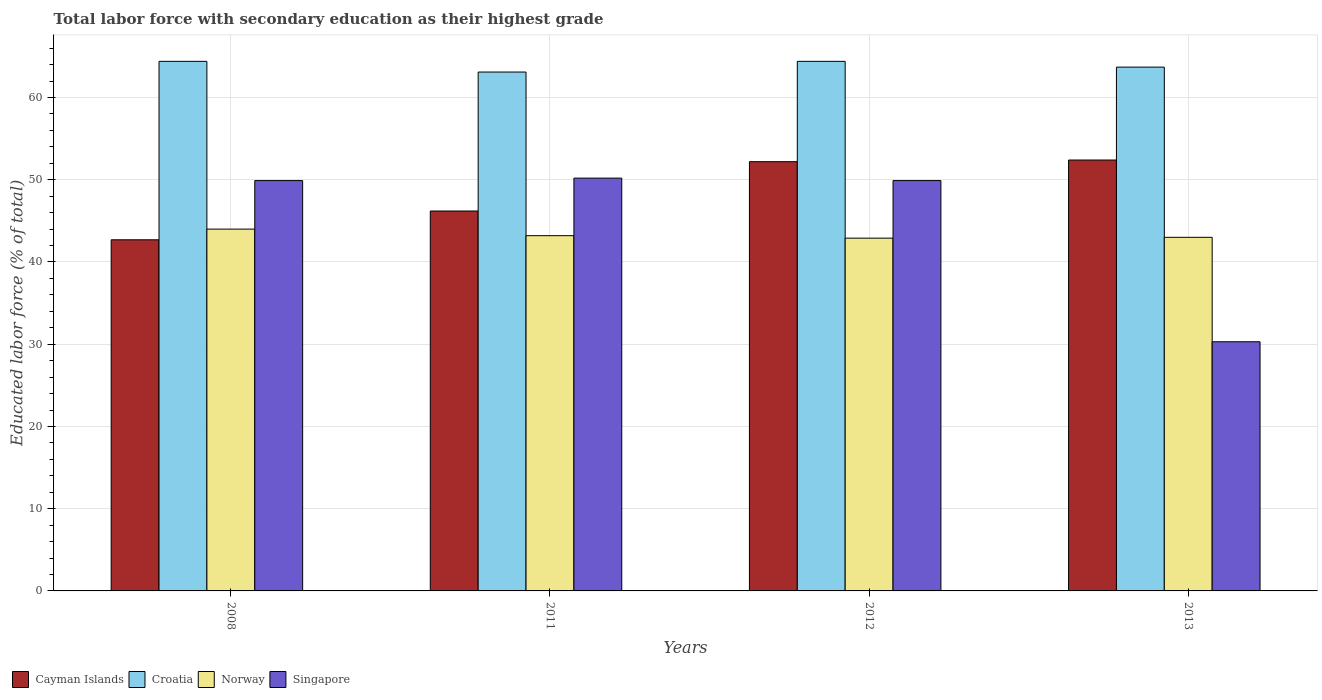Are the number of bars per tick equal to the number of legend labels?
Give a very brief answer. Yes. How many bars are there on the 1st tick from the left?
Your answer should be very brief. 4. How many bars are there on the 2nd tick from the right?
Offer a very short reply. 4. In how many cases, is the number of bars for a given year not equal to the number of legend labels?
Keep it short and to the point. 0. What is the percentage of total labor force with primary education in Croatia in 2008?
Your answer should be very brief. 64.4. Across all years, what is the maximum percentage of total labor force with primary education in Cayman Islands?
Your response must be concise. 52.4. Across all years, what is the minimum percentage of total labor force with primary education in Croatia?
Your answer should be compact. 63.1. In which year was the percentage of total labor force with primary education in Norway maximum?
Offer a terse response. 2008. What is the total percentage of total labor force with primary education in Croatia in the graph?
Offer a very short reply. 255.6. What is the difference between the percentage of total labor force with primary education in Cayman Islands in 2011 and the percentage of total labor force with primary education in Croatia in 2008?
Make the answer very short. -18.2. What is the average percentage of total labor force with primary education in Norway per year?
Provide a short and direct response. 43.28. In the year 2012, what is the difference between the percentage of total labor force with primary education in Croatia and percentage of total labor force with primary education in Norway?
Provide a short and direct response. 21.5. What is the ratio of the percentage of total labor force with primary education in Singapore in 2011 to that in 2013?
Offer a terse response. 1.66. Is the percentage of total labor force with primary education in Singapore in 2008 less than that in 2011?
Offer a very short reply. Yes. What is the difference between the highest and the second highest percentage of total labor force with primary education in Cayman Islands?
Offer a very short reply. 0.2. What is the difference between the highest and the lowest percentage of total labor force with primary education in Croatia?
Offer a very short reply. 1.3. Is it the case that in every year, the sum of the percentage of total labor force with primary education in Cayman Islands and percentage of total labor force with primary education in Singapore is greater than the sum of percentage of total labor force with primary education in Norway and percentage of total labor force with primary education in Croatia?
Your answer should be very brief. No. What does the 4th bar from the left in 2011 represents?
Your answer should be compact. Singapore. What does the 4th bar from the right in 2011 represents?
Offer a terse response. Cayman Islands. Are the values on the major ticks of Y-axis written in scientific E-notation?
Give a very brief answer. No. How are the legend labels stacked?
Ensure brevity in your answer.  Horizontal. What is the title of the graph?
Your answer should be very brief. Total labor force with secondary education as their highest grade. What is the label or title of the X-axis?
Provide a short and direct response. Years. What is the label or title of the Y-axis?
Offer a very short reply. Educated labor force (% of total). What is the Educated labor force (% of total) in Cayman Islands in 2008?
Keep it short and to the point. 42.7. What is the Educated labor force (% of total) of Croatia in 2008?
Your response must be concise. 64.4. What is the Educated labor force (% of total) of Singapore in 2008?
Keep it short and to the point. 49.9. What is the Educated labor force (% of total) of Cayman Islands in 2011?
Offer a very short reply. 46.2. What is the Educated labor force (% of total) of Croatia in 2011?
Offer a terse response. 63.1. What is the Educated labor force (% of total) in Norway in 2011?
Offer a very short reply. 43.2. What is the Educated labor force (% of total) in Singapore in 2011?
Ensure brevity in your answer.  50.2. What is the Educated labor force (% of total) of Cayman Islands in 2012?
Make the answer very short. 52.2. What is the Educated labor force (% of total) of Croatia in 2012?
Make the answer very short. 64.4. What is the Educated labor force (% of total) of Norway in 2012?
Offer a very short reply. 42.9. What is the Educated labor force (% of total) in Singapore in 2012?
Offer a very short reply. 49.9. What is the Educated labor force (% of total) of Cayman Islands in 2013?
Your answer should be compact. 52.4. What is the Educated labor force (% of total) in Croatia in 2013?
Offer a very short reply. 63.7. What is the Educated labor force (% of total) in Norway in 2013?
Your answer should be very brief. 43. What is the Educated labor force (% of total) of Singapore in 2013?
Keep it short and to the point. 30.3. Across all years, what is the maximum Educated labor force (% of total) in Cayman Islands?
Provide a succinct answer. 52.4. Across all years, what is the maximum Educated labor force (% of total) of Croatia?
Make the answer very short. 64.4. Across all years, what is the maximum Educated labor force (% of total) in Norway?
Keep it short and to the point. 44. Across all years, what is the maximum Educated labor force (% of total) in Singapore?
Your response must be concise. 50.2. Across all years, what is the minimum Educated labor force (% of total) in Cayman Islands?
Your answer should be very brief. 42.7. Across all years, what is the minimum Educated labor force (% of total) of Croatia?
Your answer should be very brief. 63.1. Across all years, what is the minimum Educated labor force (% of total) in Norway?
Provide a short and direct response. 42.9. Across all years, what is the minimum Educated labor force (% of total) of Singapore?
Make the answer very short. 30.3. What is the total Educated labor force (% of total) in Cayman Islands in the graph?
Your response must be concise. 193.5. What is the total Educated labor force (% of total) in Croatia in the graph?
Make the answer very short. 255.6. What is the total Educated labor force (% of total) of Norway in the graph?
Your answer should be very brief. 173.1. What is the total Educated labor force (% of total) in Singapore in the graph?
Ensure brevity in your answer.  180.3. What is the difference between the Educated labor force (% of total) in Cayman Islands in 2008 and that in 2011?
Offer a very short reply. -3.5. What is the difference between the Educated labor force (% of total) of Norway in 2008 and that in 2012?
Provide a succinct answer. 1.1. What is the difference between the Educated labor force (% of total) in Cayman Islands in 2008 and that in 2013?
Provide a short and direct response. -9.7. What is the difference between the Educated labor force (% of total) of Singapore in 2008 and that in 2013?
Your answer should be compact. 19.6. What is the difference between the Educated labor force (% of total) in Cayman Islands in 2011 and that in 2012?
Your response must be concise. -6. What is the difference between the Educated labor force (% of total) of Croatia in 2011 and that in 2012?
Your answer should be very brief. -1.3. What is the difference between the Educated labor force (% of total) of Norway in 2011 and that in 2012?
Provide a short and direct response. 0.3. What is the difference between the Educated labor force (% of total) in Singapore in 2011 and that in 2012?
Your response must be concise. 0.3. What is the difference between the Educated labor force (% of total) in Croatia in 2011 and that in 2013?
Make the answer very short. -0.6. What is the difference between the Educated labor force (% of total) in Norway in 2011 and that in 2013?
Ensure brevity in your answer.  0.2. What is the difference between the Educated labor force (% of total) in Singapore in 2012 and that in 2013?
Your response must be concise. 19.6. What is the difference between the Educated labor force (% of total) of Cayman Islands in 2008 and the Educated labor force (% of total) of Croatia in 2011?
Offer a very short reply. -20.4. What is the difference between the Educated labor force (% of total) of Croatia in 2008 and the Educated labor force (% of total) of Norway in 2011?
Your response must be concise. 21.2. What is the difference between the Educated labor force (% of total) of Cayman Islands in 2008 and the Educated labor force (% of total) of Croatia in 2012?
Ensure brevity in your answer.  -21.7. What is the difference between the Educated labor force (% of total) of Cayman Islands in 2008 and the Educated labor force (% of total) of Singapore in 2012?
Make the answer very short. -7.2. What is the difference between the Educated labor force (% of total) in Norway in 2008 and the Educated labor force (% of total) in Singapore in 2012?
Keep it short and to the point. -5.9. What is the difference between the Educated labor force (% of total) of Cayman Islands in 2008 and the Educated labor force (% of total) of Croatia in 2013?
Provide a succinct answer. -21. What is the difference between the Educated labor force (% of total) in Cayman Islands in 2008 and the Educated labor force (% of total) in Norway in 2013?
Keep it short and to the point. -0.3. What is the difference between the Educated labor force (% of total) in Cayman Islands in 2008 and the Educated labor force (% of total) in Singapore in 2013?
Provide a short and direct response. 12.4. What is the difference between the Educated labor force (% of total) in Croatia in 2008 and the Educated labor force (% of total) in Norway in 2013?
Make the answer very short. 21.4. What is the difference between the Educated labor force (% of total) of Croatia in 2008 and the Educated labor force (% of total) of Singapore in 2013?
Your response must be concise. 34.1. What is the difference between the Educated labor force (% of total) of Norway in 2008 and the Educated labor force (% of total) of Singapore in 2013?
Your answer should be compact. 13.7. What is the difference between the Educated labor force (% of total) of Cayman Islands in 2011 and the Educated labor force (% of total) of Croatia in 2012?
Offer a terse response. -18.2. What is the difference between the Educated labor force (% of total) of Cayman Islands in 2011 and the Educated labor force (% of total) of Norway in 2012?
Give a very brief answer. 3.3. What is the difference between the Educated labor force (% of total) in Cayman Islands in 2011 and the Educated labor force (% of total) in Singapore in 2012?
Keep it short and to the point. -3.7. What is the difference between the Educated labor force (% of total) of Croatia in 2011 and the Educated labor force (% of total) of Norway in 2012?
Provide a short and direct response. 20.2. What is the difference between the Educated labor force (% of total) in Croatia in 2011 and the Educated labor force (% of total) in Singapore in 2012?
Your response must be concise. 13.2. What is the difference between the Educated labor force (% of total) in Cayman Islands in 2011 and the Educated labor force (% of total) in Croatia in 2013?
Provide a succinct answer. -17.5. What is the difference between the Educated labor force (% of total) of Croatia in 2011 and the Educated labor force (% of total) of Norway in 2013?
Your response must be concise. 20.1. What is the difference between the Educated labor force (% of total) of Croatia in 2011 and the Educated labor force (% of total) of Singapore in 2013?
Offer a terse response. 32.8. What is the difference between the Educated labor force (% of total) in Norway in 2011 and the Educated labor force (% of total) in Singapore in 2013?
Offer a terse response. 12.9. What is the difference between the Educated labor force (% of total) of Cayman Islands in 2012 and the Educated labor force (% of total) of Singapore in 2013?
Make the answer very short. 21.9. What is the difference between the Educated labor force (% of total) in Croatia in 2012 and the Educated labor force (% of total) in Norway in 2013?
Make the answer very short. 21.4. What is the difference between the Educated labor force (% of total) of Croatia in 2012 and the Educated labor force (% of total) of Singapore in 2013?
Provide a succinct answer. 34.1. What is the average Educated labor force (% of total) in Cayman Islands per year?
Ensure brevity in your answer.  48.38. What is the average Educated labor force (% of total) in Croatia per year?
Your answer should be very brief. 63.9. What is the average Educated labor force (% of total) of Norway per year?
Your answer should be compact. 43.27. What is the average Educated labor force (% of total) of Singapore per year?
Your answer should be very brief. 45.08. In the year 2008, what is the difference between the Educated labor force (% of total) of Cayman Islands and Educated labor force (% of total) of Croatia?
Keep it short and to the point. -21.7. In the year 2008, what is the difference between the Educated labor force (% of total) of Croatia and Educated labor force (% of total) of Norway?
Ensure brevity in your answer.  20.4. In the year 2008, what is the difference between the Educated labor force (% of total) of Norway and Educated labor force (% of total) of Singapore?
Give a very brief answer. -5.9. In the year 2011, what is the difference between the Educated labor force (% of total) in Cayman Islands and Educated labor force (% of total) in Croatia?
Offer a very short reply. -16.9. In the year 2011, what is the difference between the Educated labor force (% of total) in Cayman Islands and Educated labor force (% of total) in Singapore?
Offer a terse response. -4. In the year 2012, what is the difference between the Educated labor force (% of total) of Cayman Islands and Educated labor force (% of total) of Croatia?
Provide a succinct answer. -12.2. In the year 2012, what is the difference between the Educated labor force (% of total) in Cayman Islands and Educated labor force (% of total) in Norway?
Make the answer very short. 9.3. In the year 2012, what is the difference between the Educated labor force (% of total) of Croatia and Educated labor force (% of total) of Norway?
Offer a very short reply. 21.5. In the year 2012, what is the difference between the Educated labor force (% of total) in Croatia and Educated labor force (% of total) in Singapore?
Keep it short and to the point. 14.5. In the year 2012, what is the difference between the Educated labor force (% of total) of Norway and Educated labor force (% of total) of Singapore?
Your answer should be very brief. -7. In the year 2013, what is the difference between the Educated labor force (% of total) of Cayman Islands and Educated labor force (% of total) of Croatia?
Your answer should be very brief. -11.3. In the year 2013, what is the difference between the Educated labor force (% of total) in Cayman Islands and Educated labor force (% of total) in Norway?
Ensure brevity in your answer.  9.4. In the year 2013, what is the difference between the Educated labor force (% of total) in Cayman Islands and Educated labor force (% of total) in Singapore?
Offer a very short reply. 22.1. In the year 2013, what is the difference between the Educated labor force (% of total) in Croatia and Educated labor force (% of total) in Norway?
Give a very brief answer. 20.7. In the year 2013, what is the difference between the Educated labor force (% of total) of Croatia and Educated labor force (% of total) of Singapore?
Your response must be concise. 33.4. What is the ratio of the Educated labor force (% of total) of Cayman Islands in 2008 to that in 2011?
Give a very brief answer. 0.92. What is the ratio of the Educated labor force (% of total) of Croatia in 2008 to that in 2011?
Ensure brevity in your answer.  1.02. What is the ratio of the Educated labor force (% of total) of Norway in 2008 to that in 2011?
Give a very brief answer. 1.02. What is the ratio of the Educated labor force (% of total) of Singapore in 2008 to that in 2011?
Offer a very short reply. 0.99. What is the ratio of the Educated labor force (% of total) in Cayman Islands in 2008 to that in 2012?
Offer a terse response. 0.82. What is the ratio of the Educated labor force (% of total) in Croatia in 2008 to that in 2012?
Give a very brief answer. 1. What is the ratio of the Educated labor force (% of total) in Norway in 2008 to that in 2012?
Provide a succinct answer. 1.03. What is the ratio of the Educated labor force (% of total) of Cayman Islands in 2008 to that in 2013?
Keep it short and to the point. 0.81. What is the ratio of the Educated labor force (% of total) of Norway in 2008 to that in 2013?
Your answer should be compact. 1.02. What is the ratio of the Educated labor force (% of total) in Singapore in 2008 to that in 2013?
Your answer should be very brief. 1.65. What is the ratio of the Educated labor force (% of total) of Cayman Islands in 2011 to that in 2012?
Offer a very short reply. 0.89. What is the ratio of the Educated labor force (% of total) in Croatia in 2011 to that in 2012?
Make the answer very short. 0.98. What is the ratio of the Educated labor force (% of total) in Singapore in 2011 to that in 2012?
Provide a short and direct response. 1.01. What is the ratio of the Educated labor force (% of total) of Cayman Islands in 2011 to that in 2013?
Ensure brevity in your answer.  0.88. What is the ratio of the Educated labor force (% of total) of Croatia in 2011 to that in 2013?
Offer a terse response. 0.99. What is the ratio of the Educated labor force (% of total) in Norway in 2011 to that in 2013?
Provide a succinct answer. 1. What is the ratio of the Educated labor force (% of total) of Singapore in 2011 to that in 2013?
Ensure brevity in your answer.  1.66. What is the ratio of the Educated labor force (% of total) of Cayman Islands in 2012 to that in 2013?
Your answer should be very brief. 1. What is the ratio of the Educated labor force (% of total) of Croatia in 2012 to that in 2013?
Offer a terse response. 1.01. What is the ratio of the Educated labor force (% of total) in Norway in 2012 to that in 2013?
Give a very brief answer. 1. What is the ratio of the Educated labor force (% of total) of Singapore in 2012 to that in 2013?
Make the answer very short. 1.65. What is the difference between the highest and the second highest Educated labor force (% of total) in Cayman Islands?
Provide a succinct answer. 0.2. What is the difference between the highest and the second highest Educated labor force (% of total) in Croatia?
Keep it short and to the point. 0. What is the difference between the highest and the second highest Educated labor force (% of total) in Norway?
Your answer should be compact. 0.8. What is the difference between the highest and the lowest Educated labor force (% of total) in Croatia?
Offer a very short reply. 1.3. What is the difference between the highest and the lowest Educated labor force (% of total) in Norway?
Give a very brief answer. 1.1. What is the difference between the highest and the lowest Educated labor force (% of total) of Singapore?
Provide a short and direct response. 19.9. 